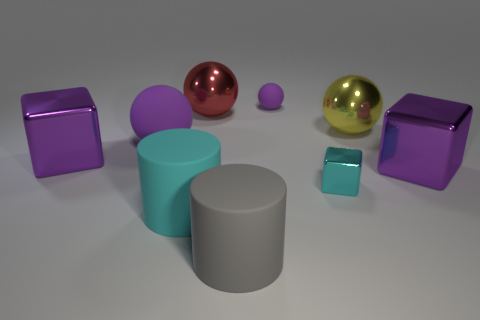What number of matte things are either large cyan cylinders or yellow things?
Offer a very short reply. 1. What is the material of the small sphere that is the same color as the big rubber ball?
Provide a short and direct response. Rubber. Does the red thing have the same size as the gray cylinder?
Keep it short and to the point. Yes. How many things are either small cubes or small purple balls that are to the right of the large purple sphere?
Ensure brevity in your answer.  2. There is a gray thing that is the same size as the yellow metallic thing; what material is it?
Offer a terse response. Rubber. What is the cube that is behind the tiny cyan metal thing and right of the tiny purple thing made of?
Your answer should be compact. Metal. There is a purple matte object that is right of the red shiny thing; are there any big cylinders behind it?
Give a very brief answer. No. How big is the rubber object that is both on the left side of the big gray matte thing and behind the big cyan cylinder?
Offer a terse response. Large. How many green things are big cylinders or big objects?
Your answer should be compact. 0. What shape is the red thing that is the same size as the yellow metallic object?
Offer a very short reply. Sphere. 